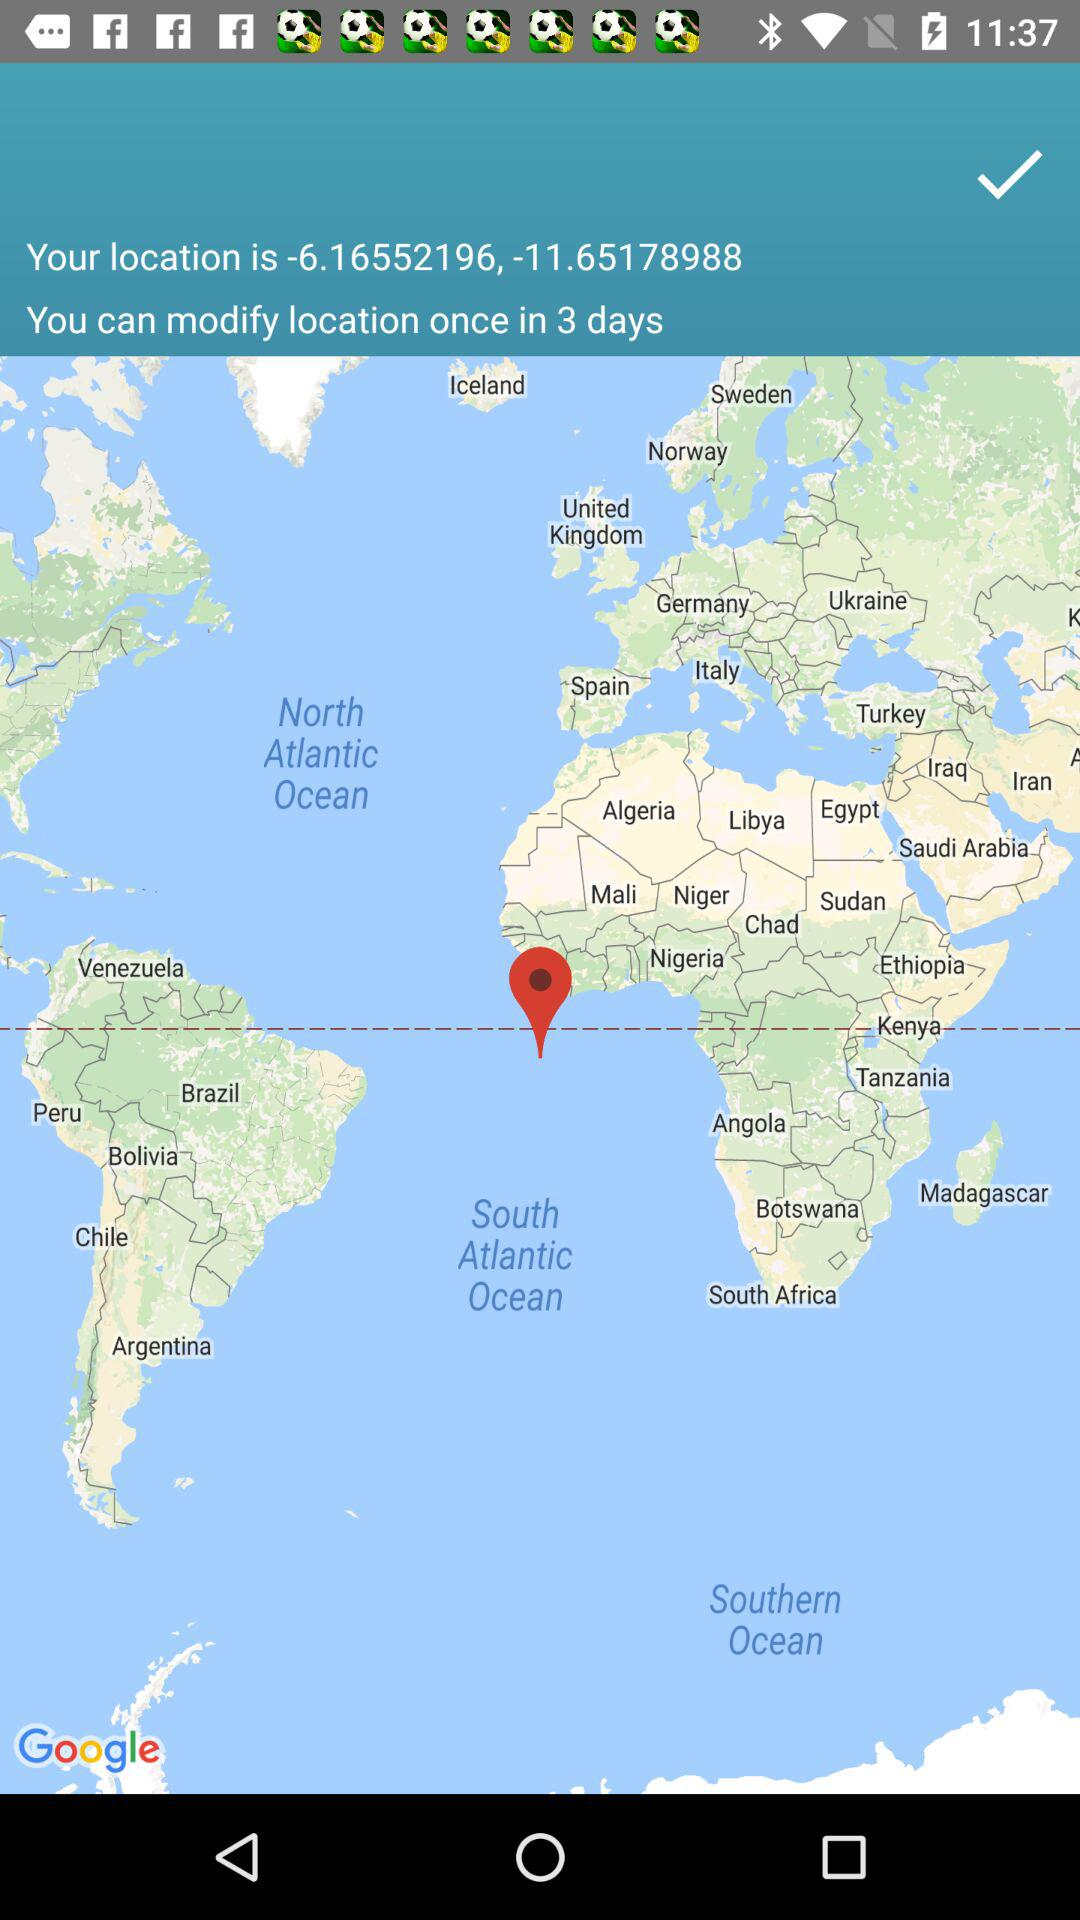What is the location? The location is -6.16552196, -11.65178988. 